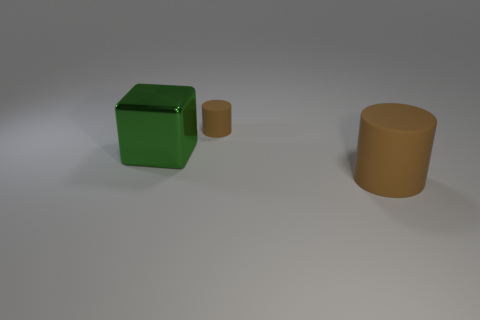There is another cylinder that is the same color as the tiny matte cylinder; what is its size?
Your answer should be compact. Large. What shape is the object that is the same color as the tiny rubber cylinder?
Your answer should be very brief. Cylinder. Is the number of big metal objects less than the number of brown rubber things?
Your answer should be compact. Yes. Is there anything else of the same color as the small matte cylinder?
Make the answer very short. Yes. What is the size of the brown matte cylinder behind the big cylinder?
Provide a short and direct response. Small. Is the number of large things greater than the number of big metallic things?
Keep it short and to the point. Yes. What material is the big block?
Make the answer very short. Metal. How many other things are there of the same material as the large cylinder?
Provide a succinct answer. 1. How many big purple metal objects are there?
Offer a very short reply. 0. What material is the tiny object that is the same shape as the big brown object?
Offer a terse response. Rubber. 